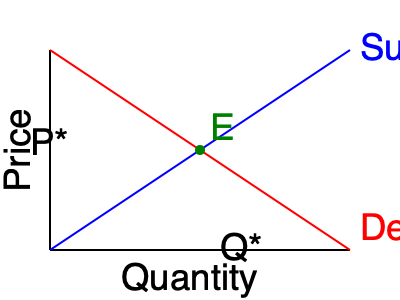As a representative from a local non-profit organization focused on economic development, you're tasked with explaining market equilibrium to a group of small business owners. Using the supply and demand curves shown in the graph, determine the equilibrium price (P*) and quantity (Q*) for this market. How would a government-imposed price floor of $8 affect this market, assuming the original equilibrium price is $6? To analyze this situation, let's follow these steps:

1. Identify the equilibrium point:
   The equilibrium point (E) is where the supply and demand curves intersect. This point represents the market equilibrium, where the quantity supplied equals the quantity demanded.

2. Determine equilibrium price and quantity:
   From the graph, we can see that the equilibrium price (P*) is $6, and the equilibrium quantity (Q*) is 100 units.

3. Understand the effects of a price floor:
   A price floor is a government-imposed minimum price for a good or service. If set above the equilibrium price, it will create a market distortion.

4. Analyze the impact of the $8 price floor:
   Since the price floor ($8) is higher than the equilibrium price ($6):
   a) The quantity supplied will increase as producers are willing to supply more at a higher price.
   b) The quantity demanded will decrease as consumers are willing to buy less at a higher price.
   c) This creates a surplus in the market, where supply exceeds demand.

5. Consequences of the price floor:
   - Excess supply (surplus) in the market
   - Decreased market efficiency
   - Potential for black market activities
   - Increased costs for consumers
   - Possible government intervention to manage surplus

In the context of economic development, this analysis helps small business owners understand how government policies can affect market dynamics and their businesses. It emphasizes the importance of adapting to changing market conditions and regulations.
Answer: Equilibrium: P* = $6, Q* = 100. $8 price floor creates surplus, decreases efficiency. 